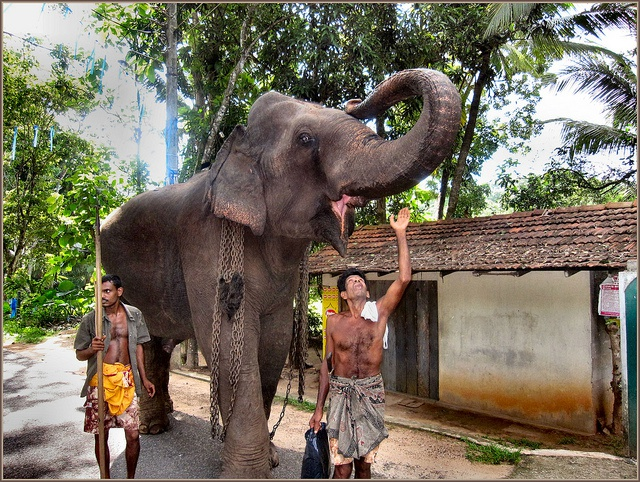Describe the objects in this image and their specific colors. I can see elephant in brown, black, and gray tones, people in brown, darkgray, gray, and maroon tones, people in brown, maroon, black, and gray tones, and handbag in brown, black, and gray tones in this image. 